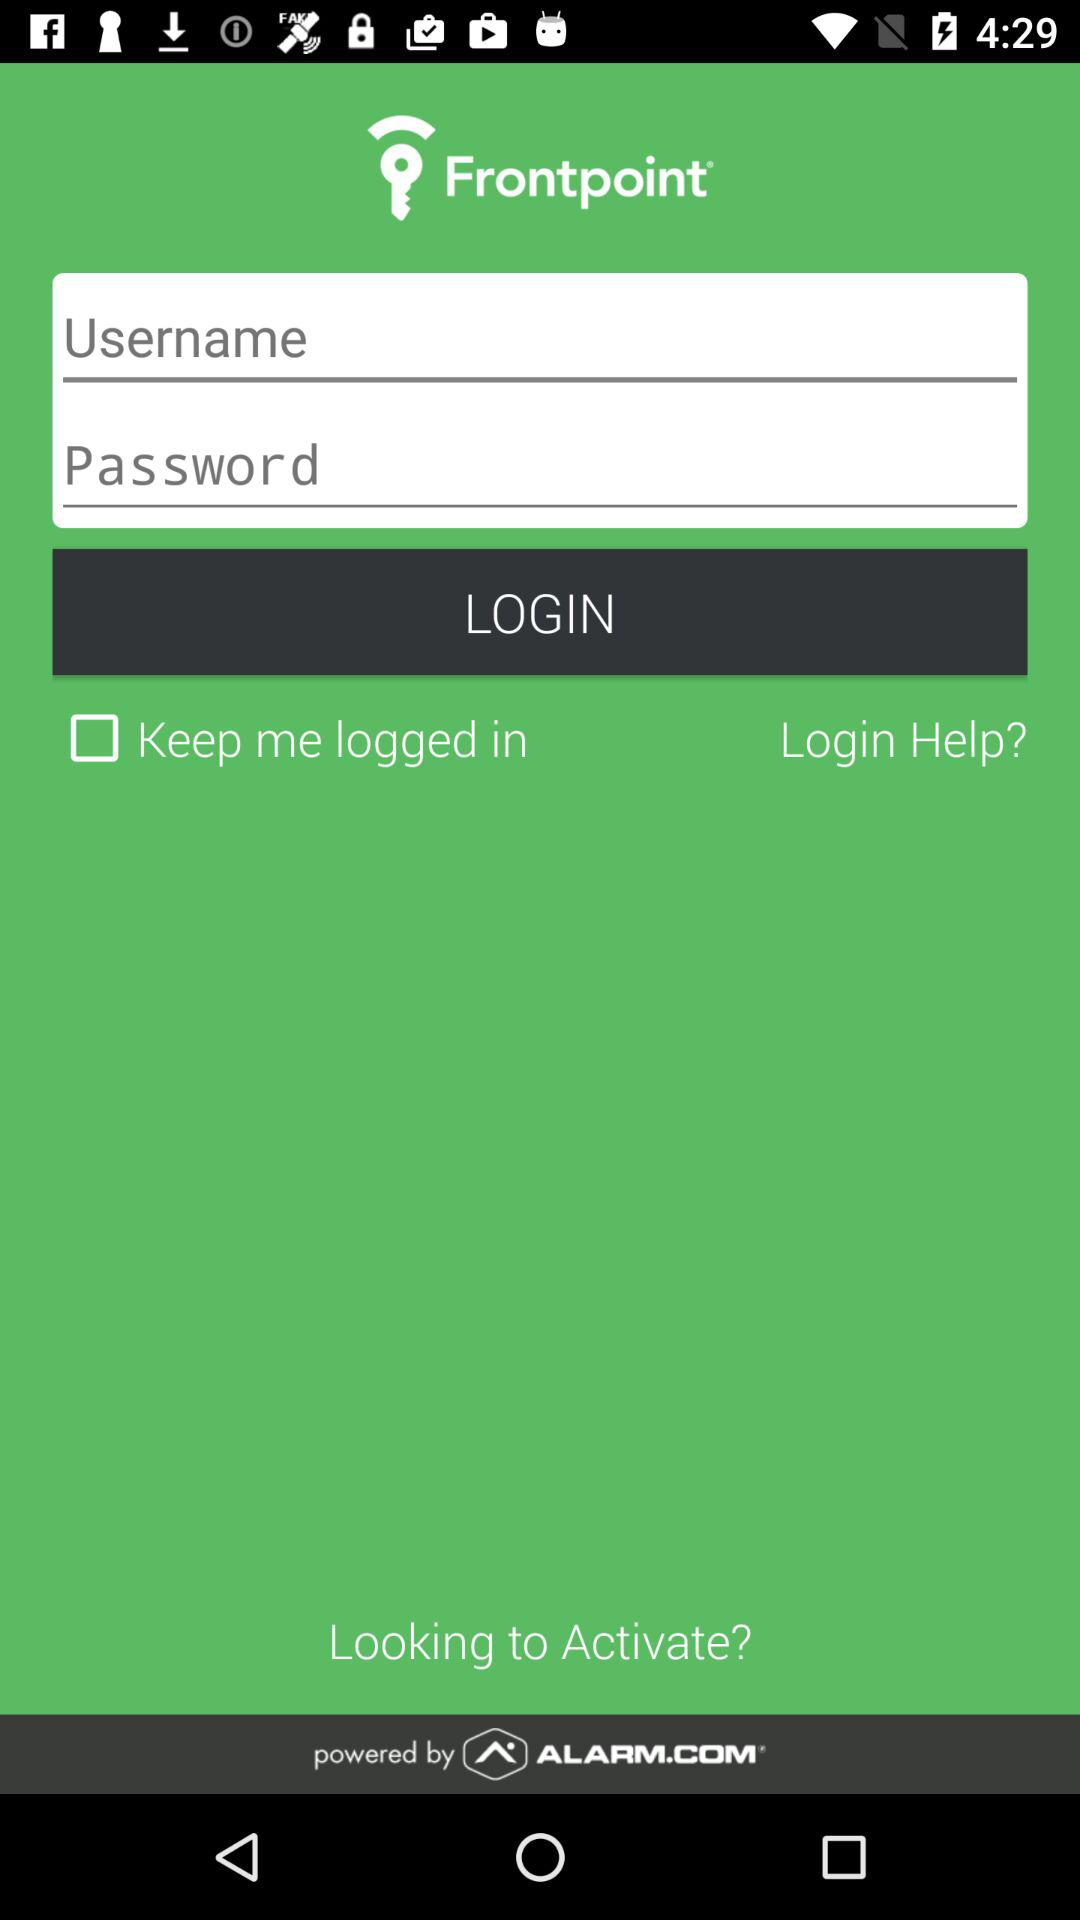What is the application name? The application name is "Frontpoint". 